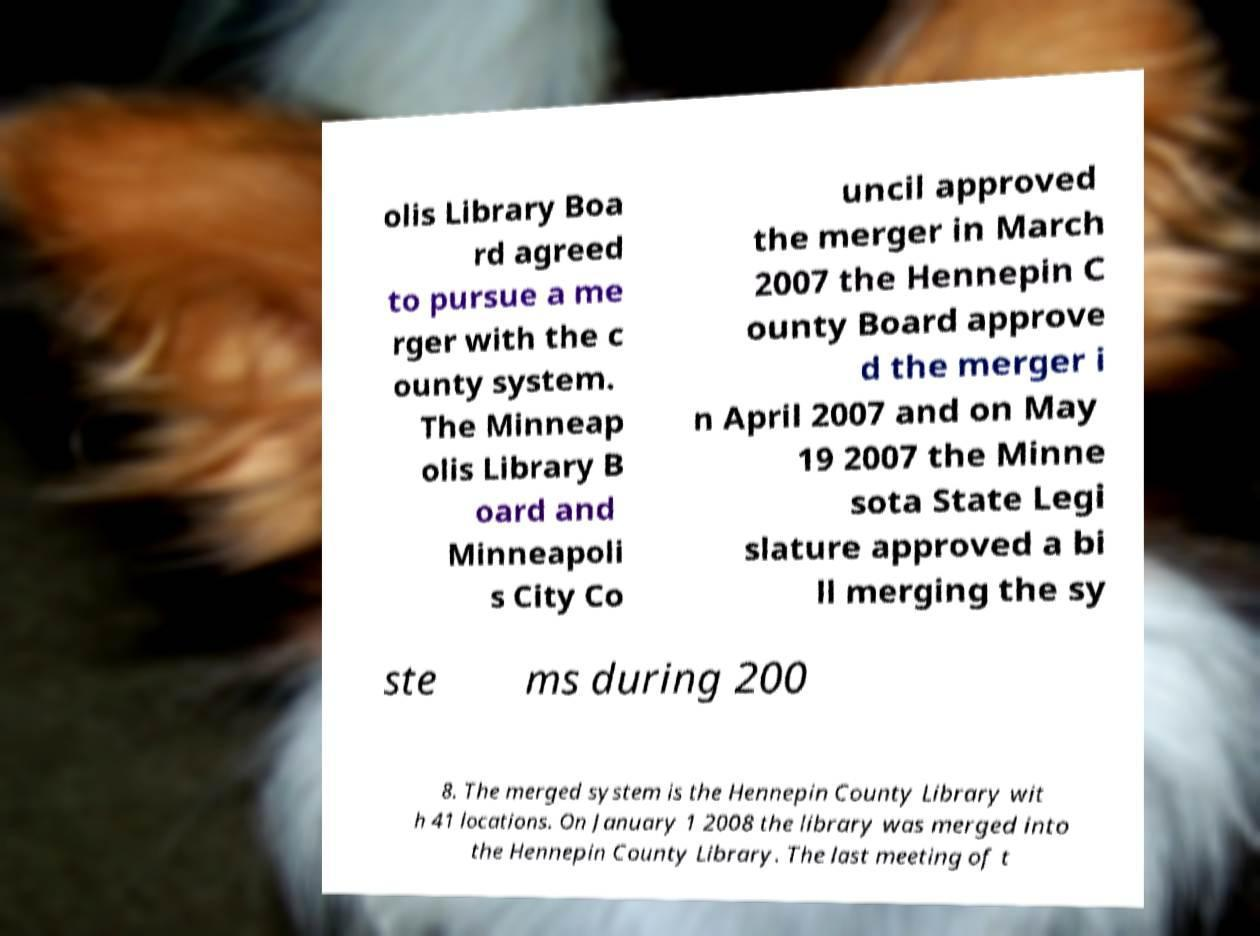Can you accurately transcribe the text from the provided image for me? olis Library Boa rd agreed to pursue a me rger with the c ounty system. The Minneap olis Library B oard and Minneapoli s City Co uncil approved the merger in March 2007 the Hennepin C ounty Board approve d the merger i n April 2007 and on May 19 2007 the Minne sota State Legi slature approved a bi ll merging the sy ste ms during 200 8. The merged system is the Hennepin County Library wit h 41 locations. On January 1 2008 the library was merged into the Hennepin County Library. The last meeting of t 